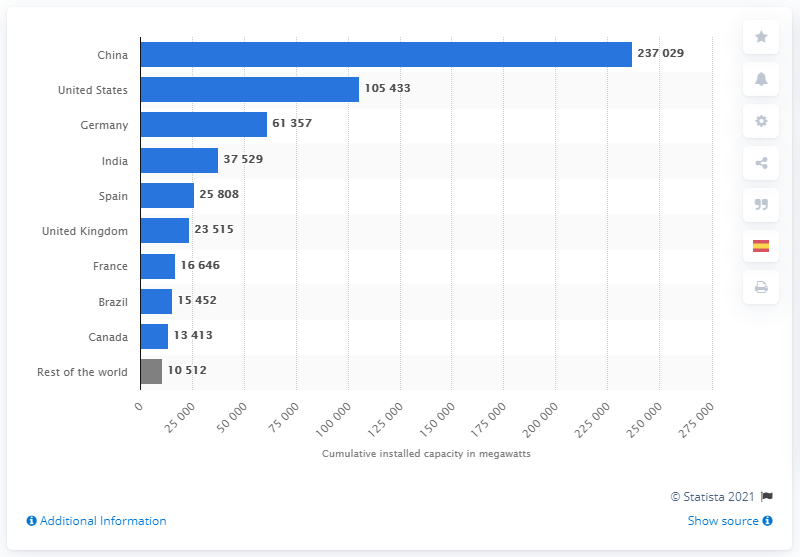Indicate a few pertinent items in this graphic. The largest installer of wind power capacity in the world is China. 